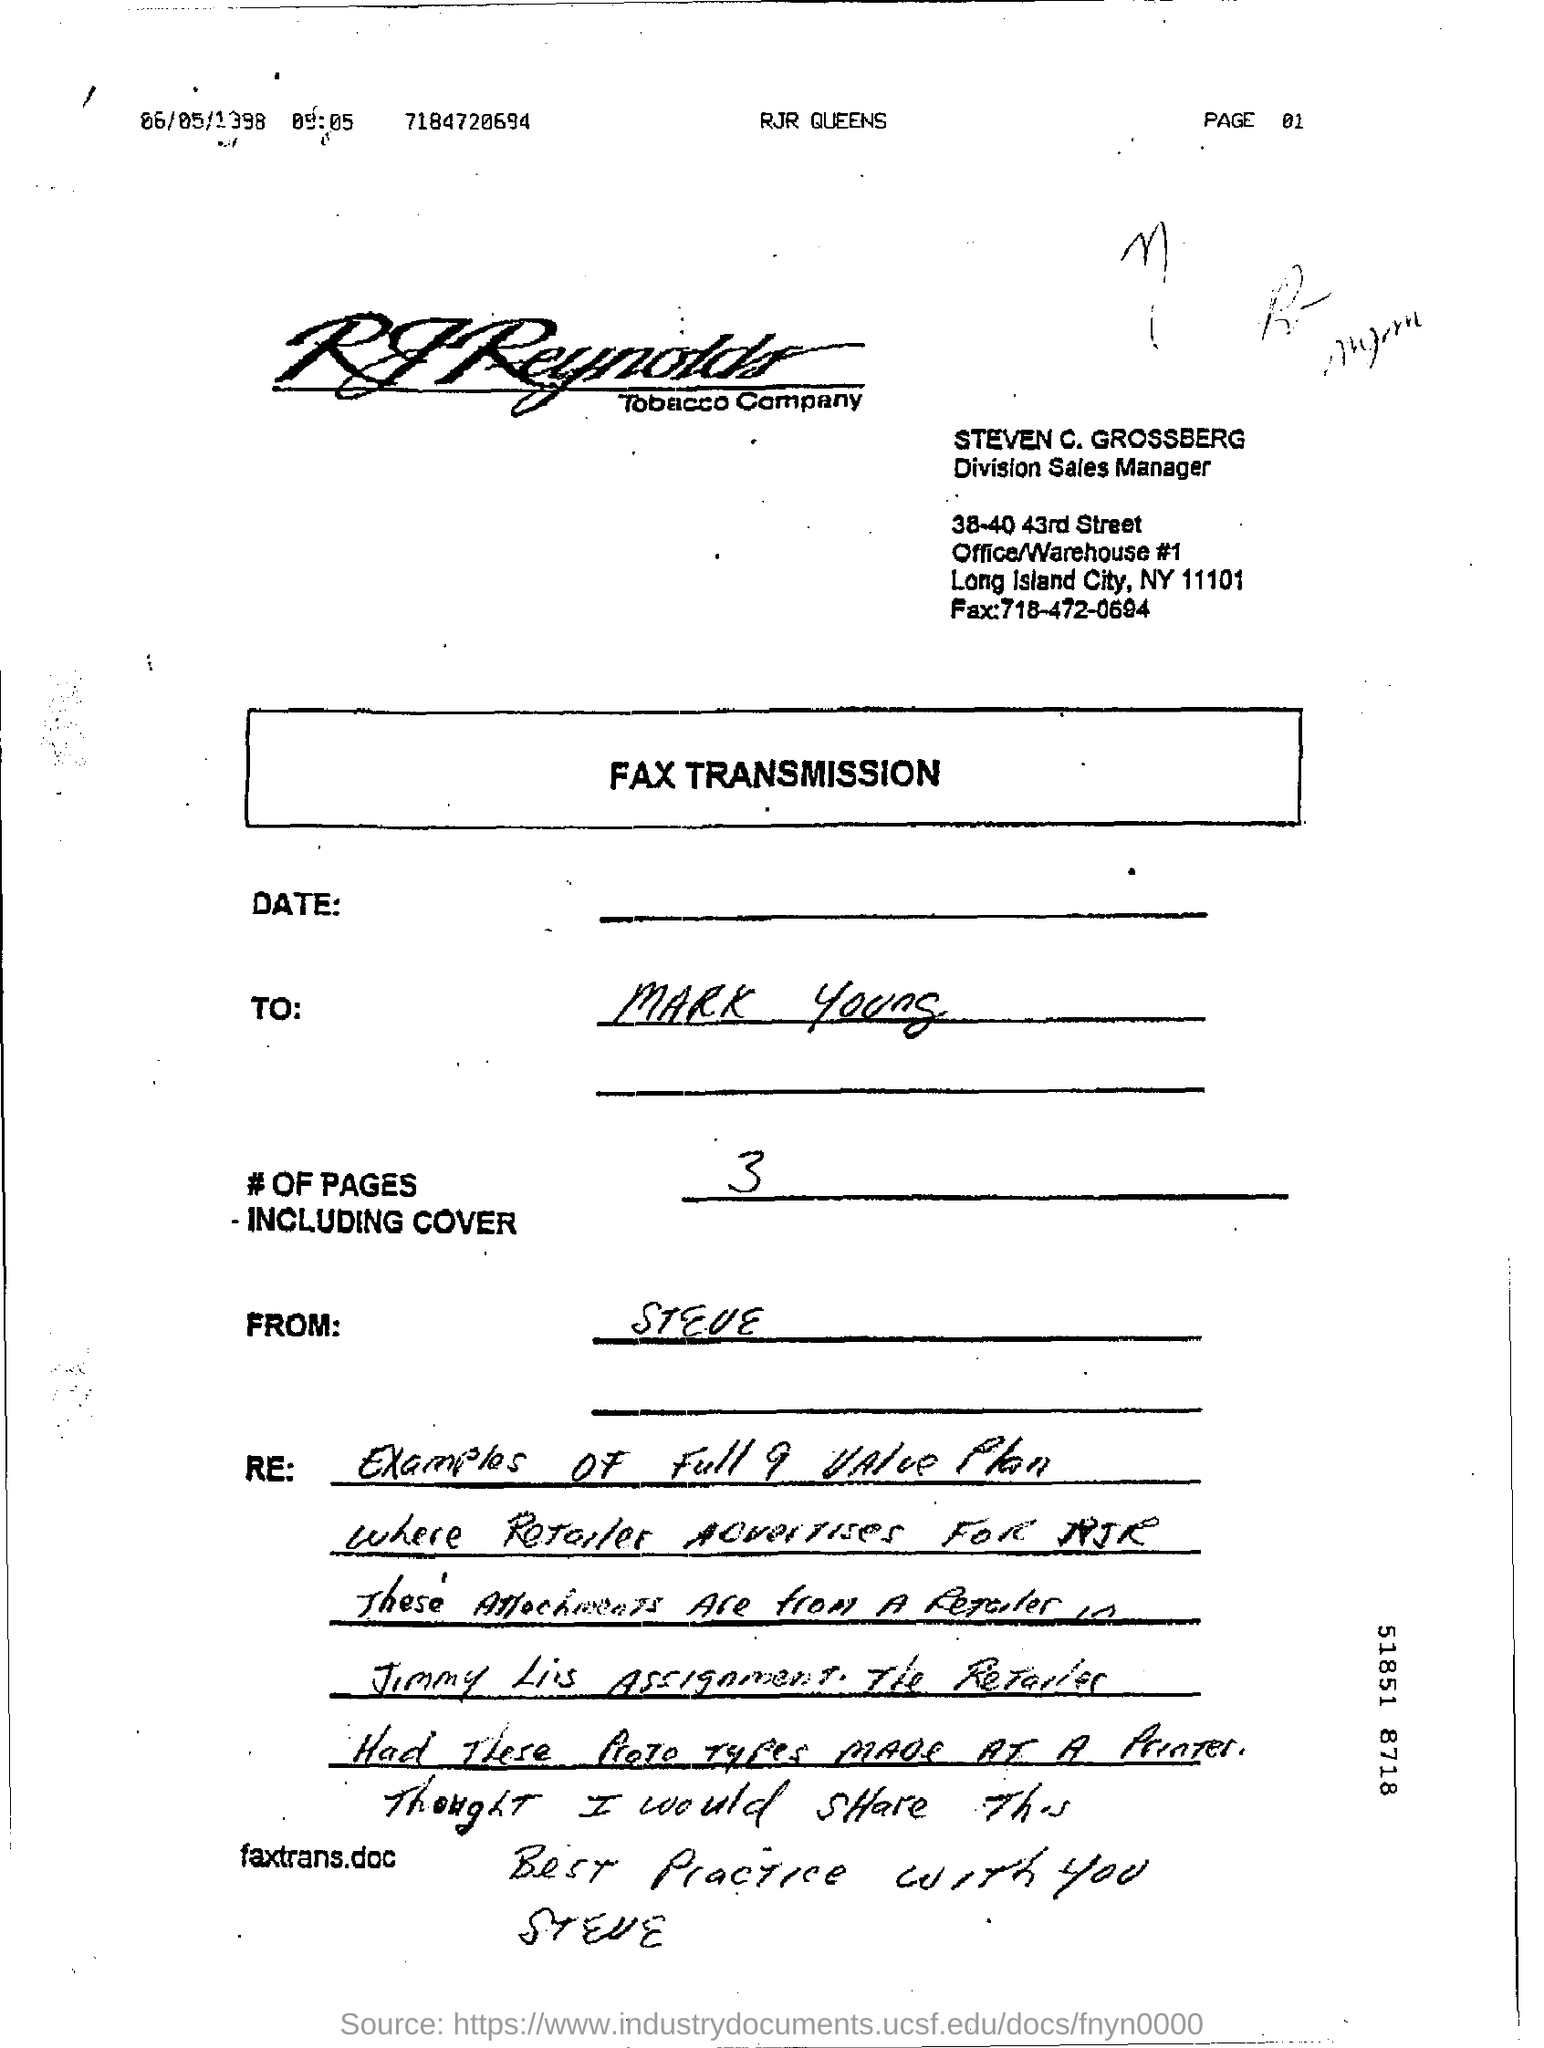Which company's fax transmission is this?
Your response must be concise. RJ Reynolds Tobacco Company. Who is the receiver of the fax?
Your response must be concise. Mark Young. Who is the sender of the Fax?
Ensure brevity in your answer.  Steve. What is the no of pages in the fax including cover?
Ensure brevity in your answer.  3. What is the designation of Steven C. Grossberg?
Provide a short and direct response. Division Sales Manager. What is the fax no of Steven C. Grossberg?
Your response must be concise. 718-472-0694. 